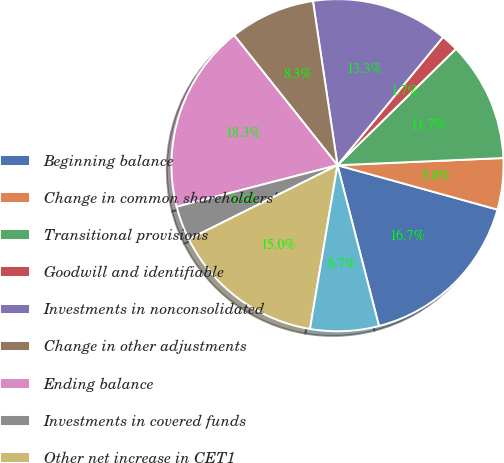Convert chart. <chart><loc_0><loc_0><loc_500><loc_500><pie_chart><fcel>Beginning balance<fcel>Change in common shareholders'<fcel>Transitional provisions<fcel>Goodwill and identifiable<fcel>Investments in nonconsolidated<fcel>Change in other adjustments<fcel>Ending balance<fcel>Investments in covered funds<fcel>Other net increase in CET1<fcel>Redesignation of junior<nl><fcel>16.67%<fcel>5.0%<fcel>11.67%<fcel>1.67%<fcel>13.33%<fcel>8.33%<fcel>18.33%<fcel>3.33%<fcel>15.0%<fcel>6.67%<nl></chart> 